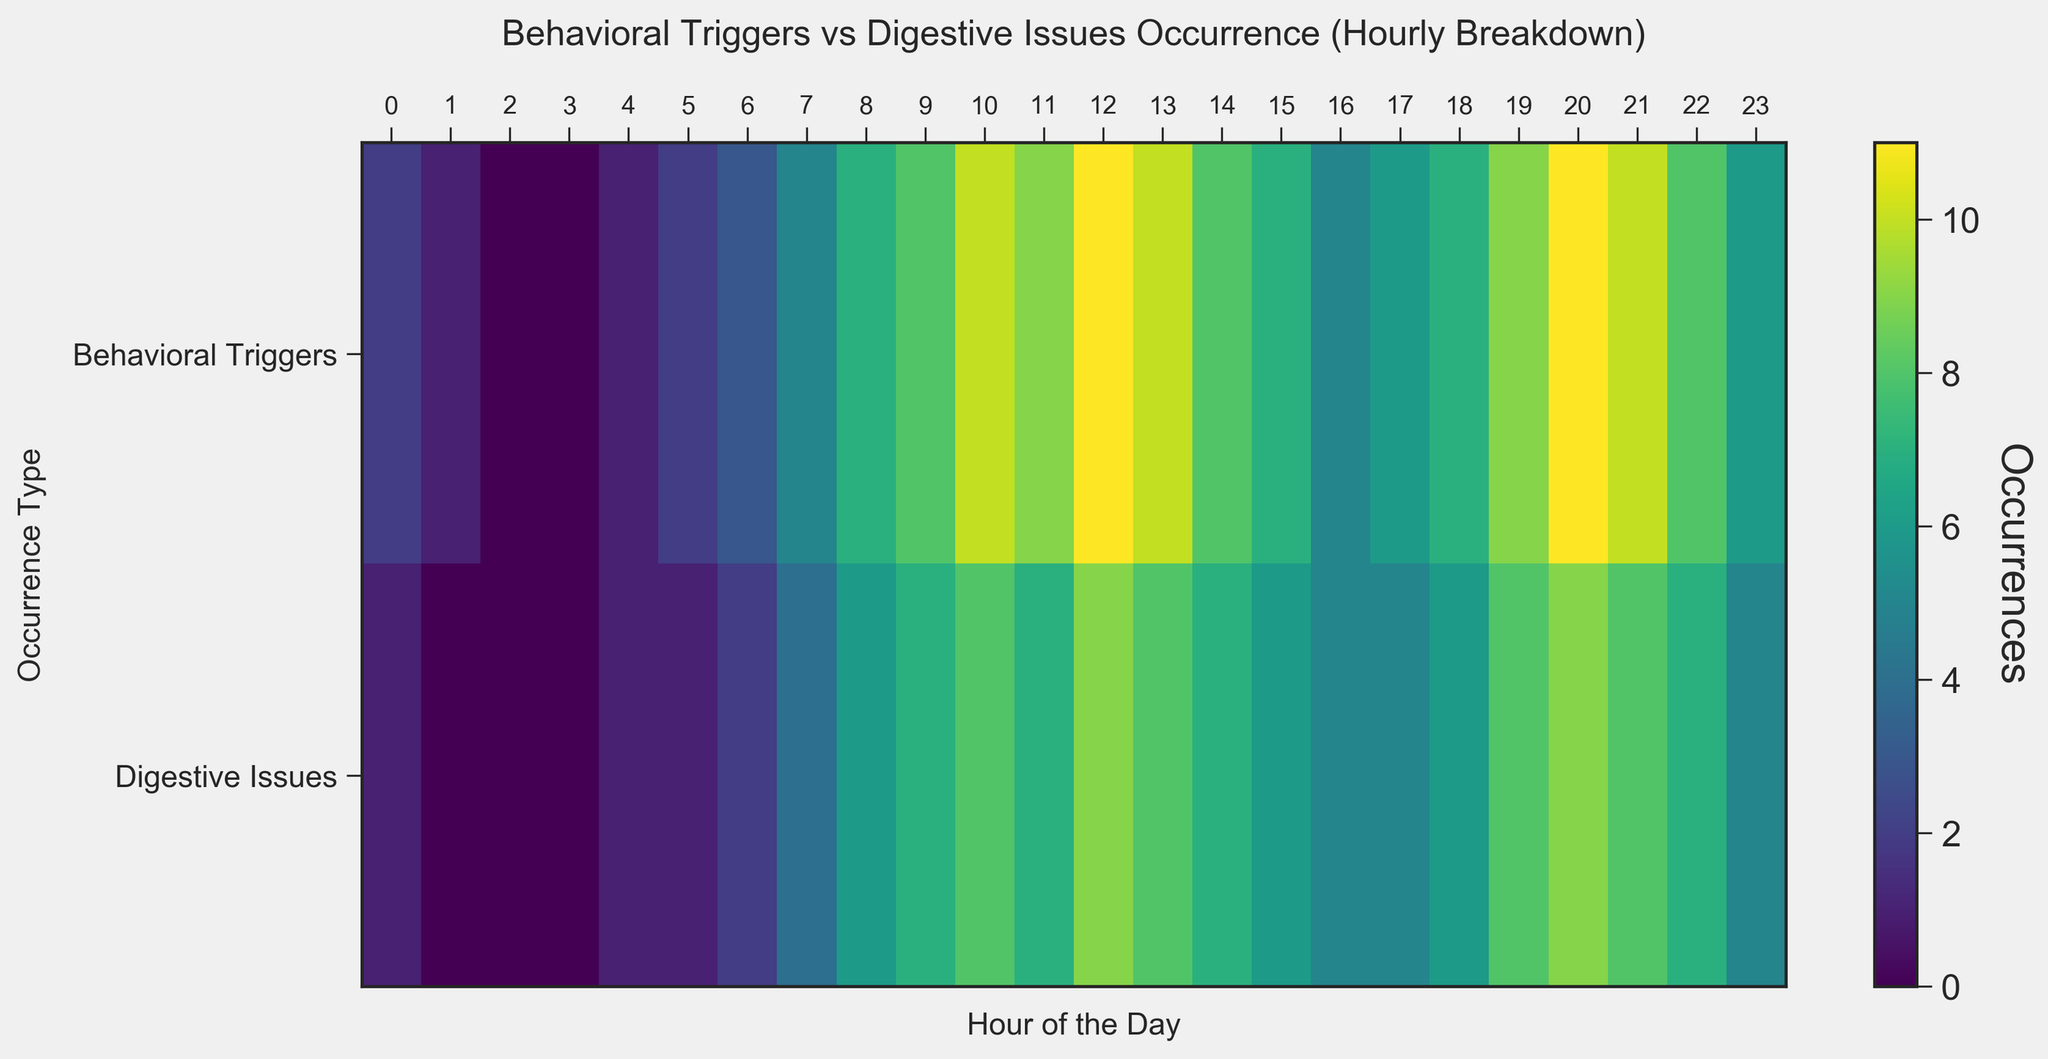What time period has the highest number of combined behavioral triggers and digestive issues? To determine this, sum the occurrences of behavioral triggers and digestive issues for each hour, then identify the hour with the highest total. The hour with the highest combined value is 12 (11 behavioral triggers + 9 digestive issues = 20).
Answer: 12 Between which hours is there a significant increase in behavioral triggers? Examine the heatmap's color intensity for behavioral triggers from one hour to the next. The significant increase occurs from 6 AM to 7 AM, where occurrences jump from 3 to 5.
Answer: 6 to 7 AM At what hour of the day do behavioral triggers and digestive issues both first reach a value of 10 or more? Observe the heatmap to find the earliest time both occurrences hit at least 10. This happens at hour 10, where behavioral triggers are 10 and digestive issues are 8, and subsequently at hour 11 where both are 10 or more.
Answer: 11 During which time frame do we observe a consistent pattern where behavioral triggers are consistently greater than digestive issues for at least three hours? Look for a sequence of consecutive hours where behavioral triggers' color intensity is consistently higher than that of digestive issues. This pattern is observed from 7 AM to 11 AM.
Answer: 7 to 11 AM When comparing 8 PM and 8 AM, which hour has more digestive issues? Compare the color intensity representing digestive issues at 8 AM and 8 PM. 8 AM shows 6 digestive issues, whereas 8 PM shows 9.
Answer: 8 PM What's the average number of behavioral trigger occurrences during peak digestive issues (hours with 9 or more digestive issues)? Identify hours with 9 or more digestive issues (12, 20), and calculate the average of the corresponding behavioral triggers (11, 11). (11 + 11) / 2 = 11
Answer: 11 During which hour is the discrepancy between behavioral triggers and digestive issues occurrence the smallest? Calculate the absolute difference between behavioral triggers and digestive issues for each hour, then find the hour with the smallest difference. The smallest discrepancy happens at 5 PM where both are 5.
Answer: 5 PM Do behavioral triggers and digestive issue occurrences both generally increase or decrease throughout the day? Examine the trend of color intensity from early morning to late evening. Both behavioral triggers and digestive issues generally increase until noon and then follow a fluctuating rather than strictly declining pattern.
Answer: Increase until noon, then fluctuate 